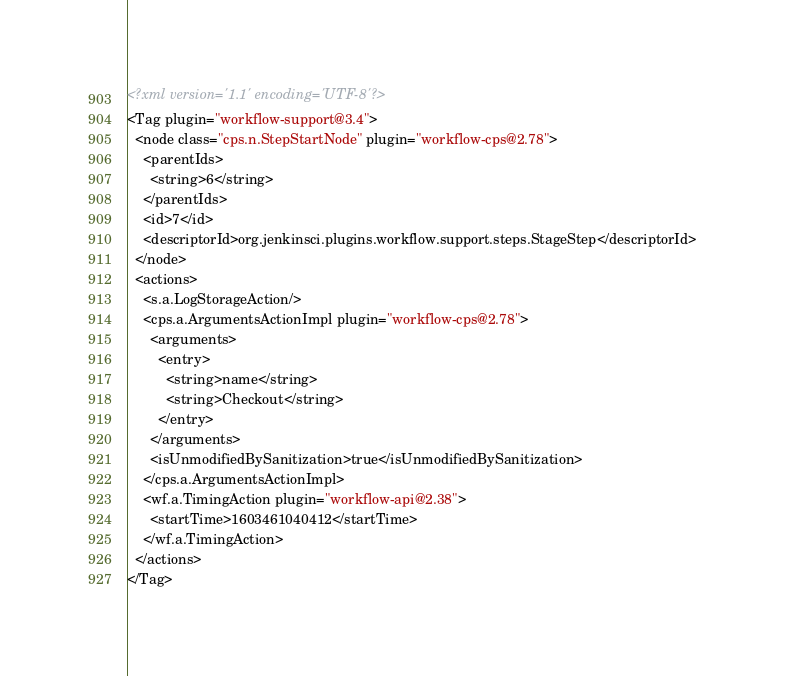<code> <loc_0><loc_0><loc_500><loc_500><_XML_><?xml version='1.1' encoding='UTF-8'?>
<Tag plugin="workflow-support@3.4">
  <node class="cps.n.StepStartNode" plugin="workflow-cps@2.78">
    <parentIds>
      <string>6</string>
    </parentIds>
    <id>7</id>
    <descriptorId>org.jenkinsci.plugins.workflow.support.steps.StageStep</descriptorId>
  </node>
  <actions>
    <s.a.LogStorageAction/>
    <cps.a.ArgumentsActionImpl plugin="workflow-cps@2.78">
      <arguments>
        <entry>
          <string>name</string>
          <string>Checkout</string>
        </entry>
      </arguments>
      <isUnmodifiedBySanitization>true</isUnmodifiedBySanitization>
    </cps.a.ArgumentsActionImpl>
    <wf.a.TimingAction plugin="workflow-api@2.38">
      <startTime>1603461040412</startTime>
    </wf.a.TimingAction>
  </actions>
</Tag></code> 